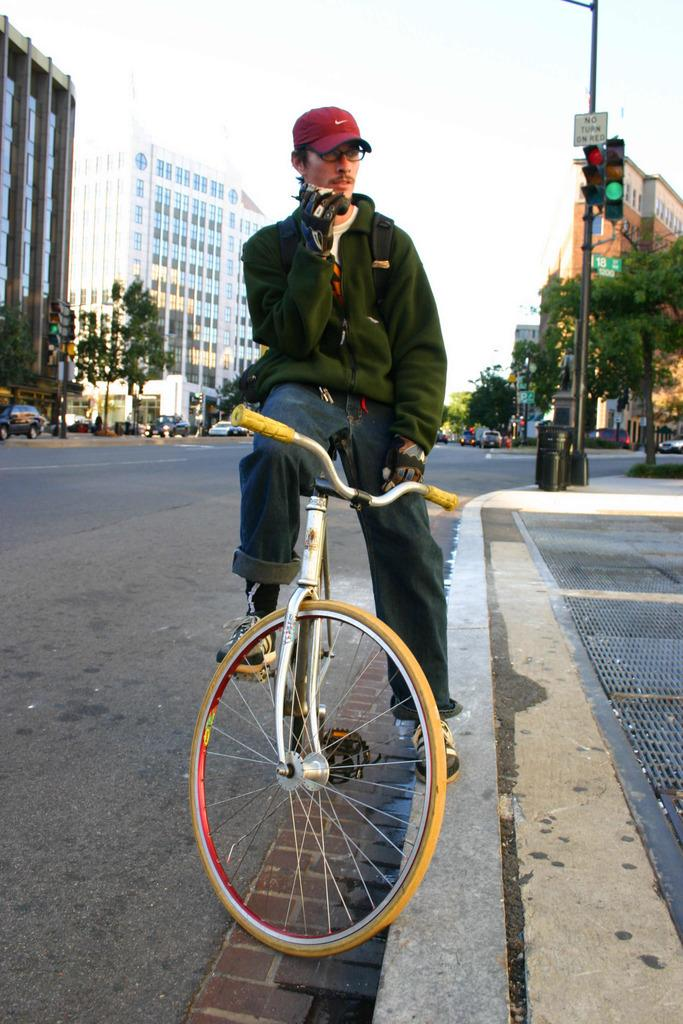What is the person in the image doing? The person is sitting on a bicycle. What accessories is the person wearing? The person is wearing a cap and glasses. What can be seen in the background of the image? There are buildings and trees visible in the background. What else is present on the road in the image? There are vehicles on the road. What is used to control traffic in the image? There is a pole with a traffic signal. What type of marble is being used to decorate the pies in the image? There are no pies or marble present in the image; it features a person sitting on a bicycle with a background of buildings, trees, vehicles, and a traffic signal. 